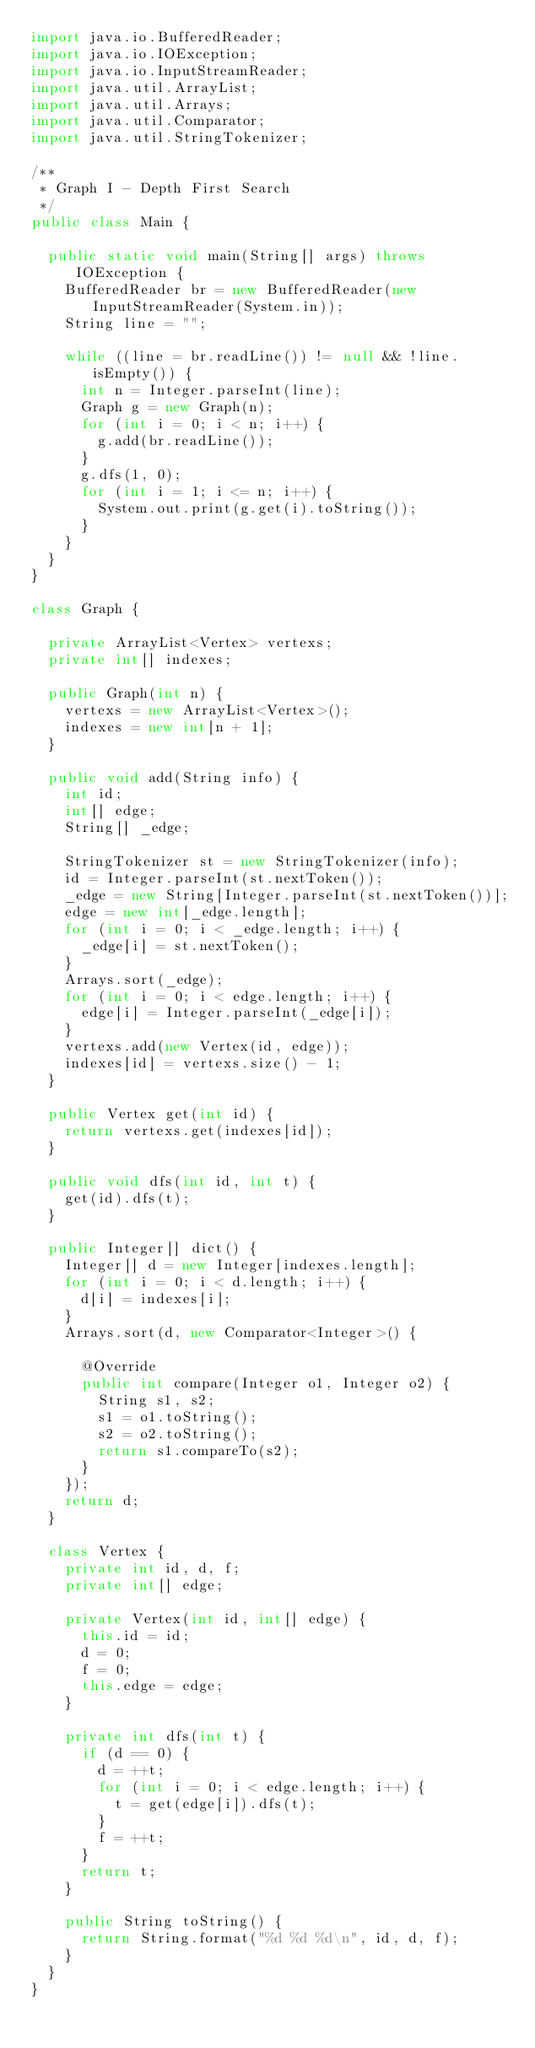Convert code to text. <code><loc_0><loc_0><loc_500><loc_500><_Java_>import java.io.BufferedReader;
import java.io.IOException;
import java.io.InputStreamReader;
import java.util.ArrayList;
import java.util.Arrays;
import java.util.Comparator;
import java.util.StringTokenizer;

/**
 * Graph I - Depth First Search
 */
public class Main {

	public static void main(String[] args) throws IOException {
		BufferedReader br = new BufferedReader(new InputStreamReader(System.in));
		String line = "";

		while ((line = br.readLine()) != null && !line.isEmpty()) {
			int n = Integer.parseInt(line);
			Graph g = new Graph(n);
			for (int i = 0; i < n; i++) {
				g.add(br.readLine());
			}
			g.dfs(1, 0);
			for (int i = 1; i <= n; i++) {
				System.out.print(g.get(i).toString());
			}
		}
	}
}

class Graph {

	private ArrayList<Vertex> vertexs;
	private int[] indexes;

	public Graph(int n) {
		vertexs = new ArrayList<Vertex>();
		indexes = new int[n + 1];
	}

	public void add(String info) {
		int id;
		int[] edge;
		String[] _edge;

		StringTokenizer st = new StringTokenizer(info);
		id = Integer.parseInt(st.nextToken());
		_edge = new String[Integer.parseInt(st.nextToken())];
		edge = new int[_edge.length];
		for (int i = 0; i < _edge.length; i++) {
			_edge[i] = st.nextToken();
		}
		Arrays.sort(_edge);
		for (int i = 0; i < edge.length; i++) {
			edge[i] = Integer.parseInt(_edge[i]);
		}
		vertexs.add(new Vertex(id, edge));
		indexes[id] = vertexs.size() - 1;
	}

	public Vertex get(int id) {
		return vertexs.get(indexes[id]);
	}

	public void dfs(int id, int t) {
		get(id).dfs(t);
	}

	public Integer[] dict() {
		Integer[] d = new Integer[indexes.length];
		for (int i = 0; i < d.length; i++) {
			d[i] = indexes[i];
		}
		Arrays.sort(d, new Comparator<Integer>() {

			@Override
			public int compare(Integer o1, Integer o2) {
				String s1, s2;
				s1 = o1.toString();
				s2 = o2.toString();
				return s1.compareTo(s2);
			}
		});
		return d;
	}

	class Vertex {
		private int id, d, f;
		private int[] edge;

		private Vertex(int id, int[] edge) {
			this.id = id;
			d = 0;
			f = 0;
			this.edge = edge;
		}

		private int dfs(int t) {
			if (d == 0) {
				d = ++t;
				for (int i = 0; i < edge.length; i++) {
					t = get(edge[i]).dfs(t);
				}
				f = ++t;
			}
			return t;
		}

		public String toString() {
			return String.format("%d %d %d\n", id, d, f);
		}
	}
}</code> 